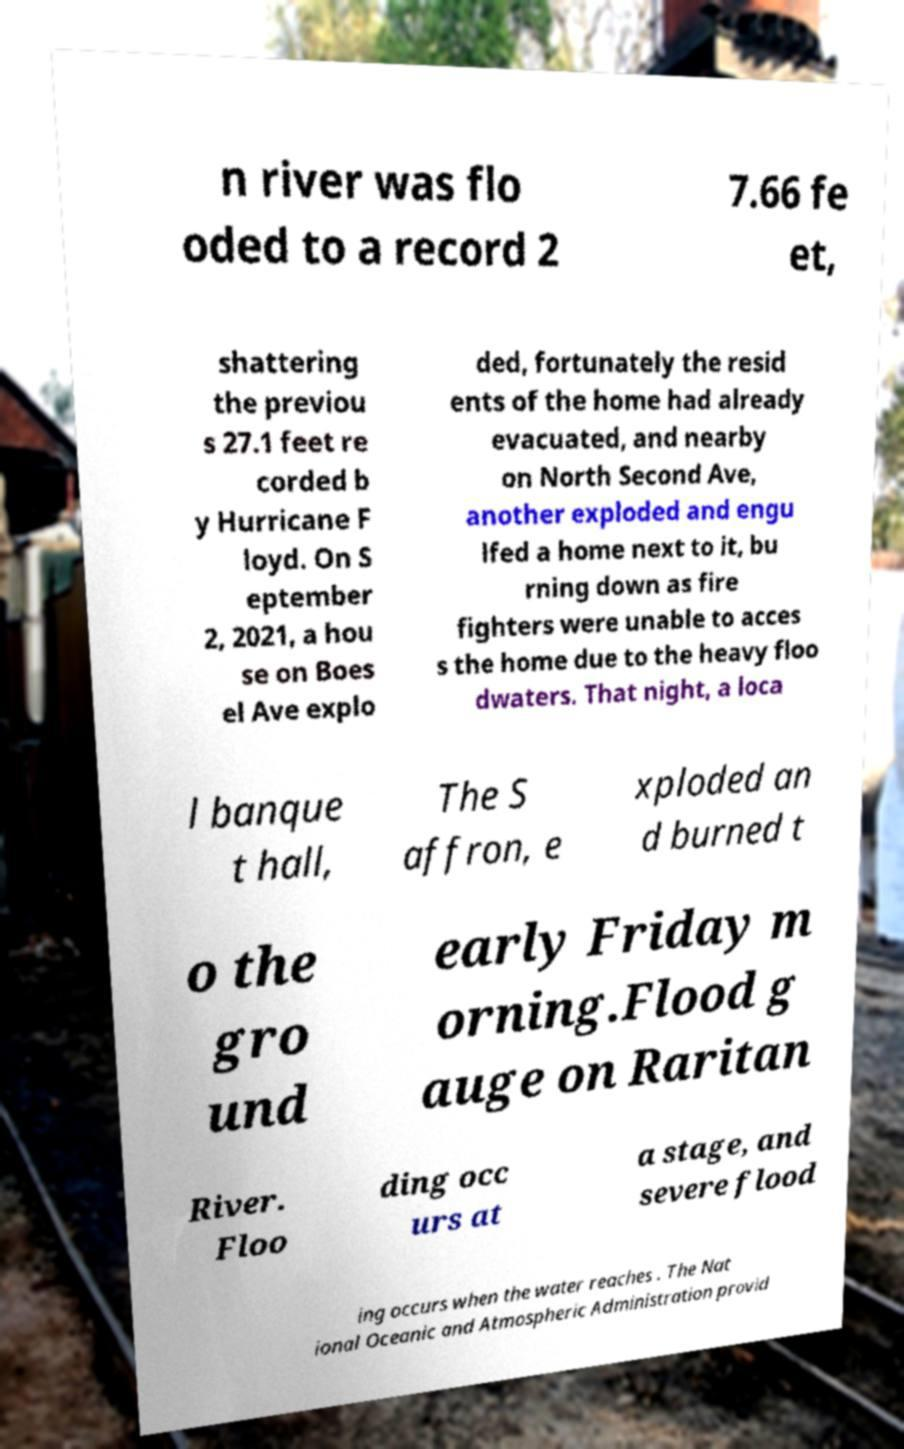Can you read and provide the text displayed in the image?This photo seems to have some interesting text. Can you extract and type it out for me? n river was flo oded to a record 2 7.66 fe et, shattering the previou s 27.1 feet re corded b y Hurricane F loyd. On S eptember 2, 2021, a hou se on Boes el Ave explo ded, fortunately the resid ents of the home had already evacuated, and nearby on North Second Ave, another exploded and engu lfed a home next to it, bu rning down as fire fighters were unable to acces s the home due to the heavy floo dwaters. That night, a loca l banque t hall, The S affron, e xploded an d burned t o the gro und early Friday m orning.Flood g auge on Raritan River. Floo ding occ urs at a stage, and severe flood ing occurs when the water reaches . The Nat ional Oceanic and Atmospheric Administration provid 